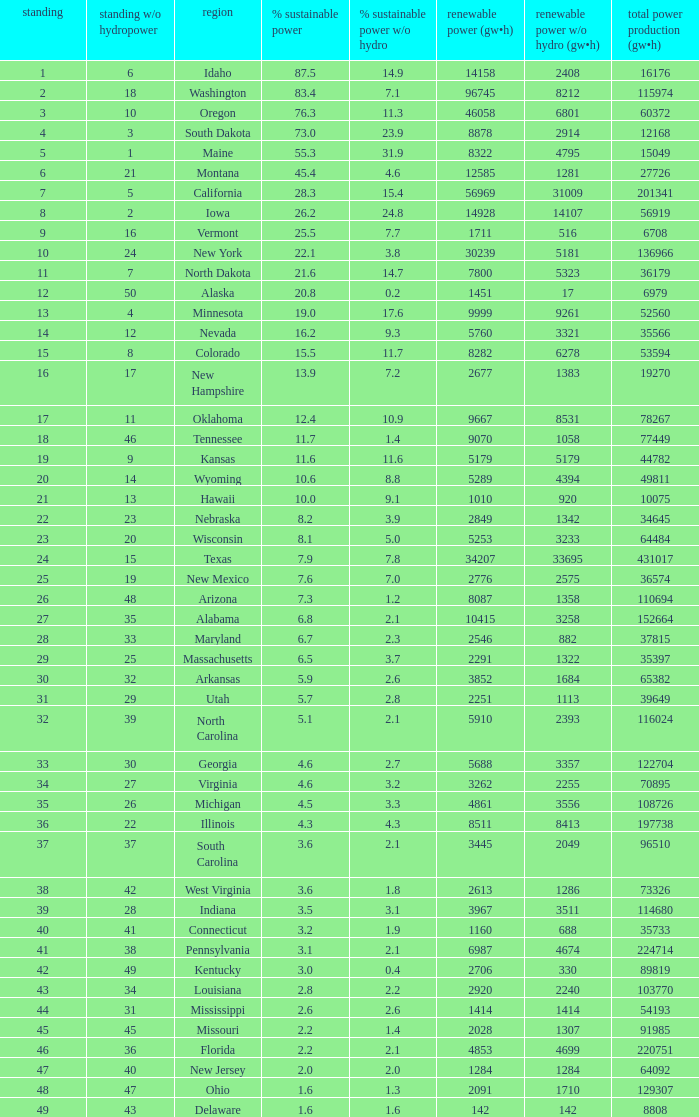Which state has 5179 (gw×h) of renewable energy without hydrogen power?wha Kansas. 